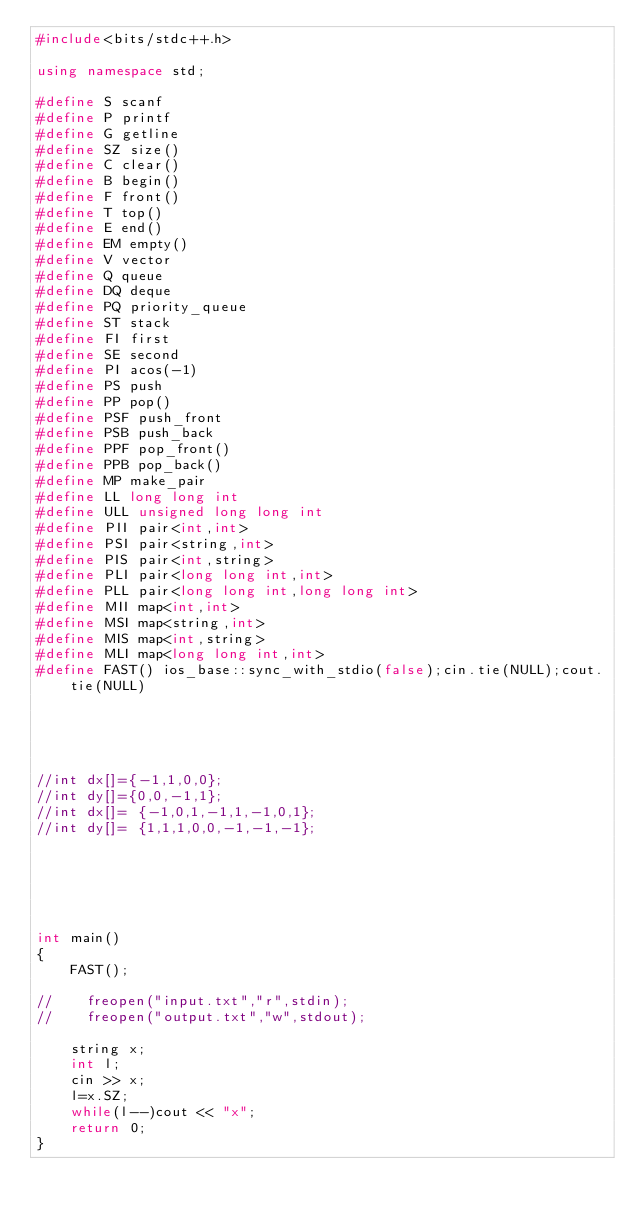Convert code to text. <code><loc_0><loc_0><loc_500><loc_500><_C++_>#include<bits/stdc++.h>

using namespace std;

#define S scanf
#define P printf
#define G getline
#define SZ size()
#define C clear()
#define B begin()
#define F front()
#define T top()
#define E end()
#define EM empty()
#define V vector
#define Q queue
#define DQ deque
#define PQ priority_queue
#define ST stack
#define FI first
#define SE second
#define PI acos(-1)
#define PS push
#define PP pop()
#define PSF push_front
#define PSB push_back
#define PPF pop_front()
#define PPB pop_back()
#define MP make_pair
#define LL long long int
#define ULL unsigned long long int
#define PII pair<int,int>
#define PSI pair<string,int>
#define PIS pair<int,string>
#define PLI pair<long long int,int>
#define PLL pair<long long int,long long int>
#define MII map<int,int>
#define MSI map<string,int>
#define MIS map<int,string>
#define MLI map<long long int,int>
#define FAST() ios_base::sync_with_stdio(false);cin.tie(NULL);cout.tie(NULL)





//int dx[]={-1,1,0,0};
//int dy[]={0,0,-1,1};
//int dx[]= {-1,0,1,-1,1,-1,0,1};
//int dy[]= {1,1,1,0,0,-1,-1,-1};






int main()
{
    FAST();

//    freopen("input.txt","r",stdin);
//    freopen("output.txt","w",stdout);

    string x;
    int l;
    cin >> x;
    l=x.SZ;
    while(l--)cout << "x";
    return 0;
}
</code> 